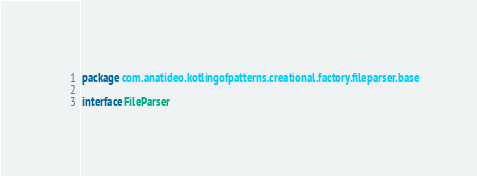<code> <loc_0><loc_0><loc_500><loc_500><_Kotlin_>package com.anatideo.kotlingofpatterns.creational.factory.fileparser.base

interface FileParser</code> 